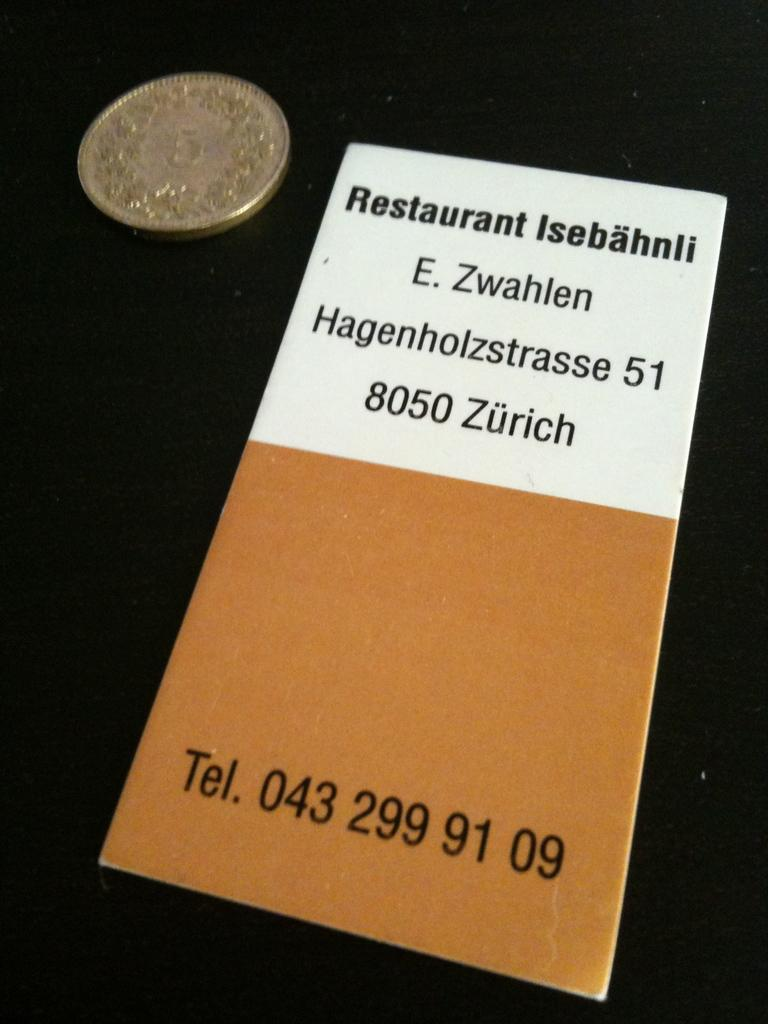<image>
Offer a succinct explanation of the picture presented. A menu lists the phone number and an address in Zurich. 